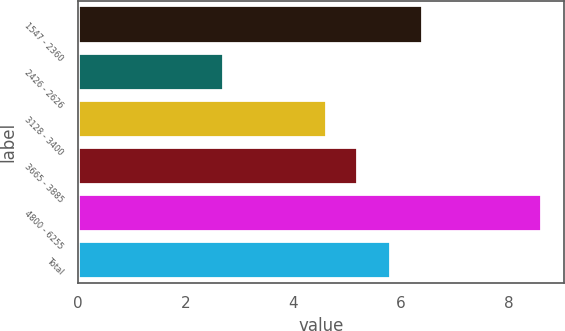Convert chart. <chart><loc_0><loc_0><loc_500><loc_500><bar_chart><fcel>1547 - 2360<fcel>2426 - 2626<fcel>3128 - 3400<fcel>3665 - 3885<fcel>4800 - 6255<fcel>Total<nl><fcel>6.39<fcel>2.7<fcel>4.6<fcel>5.19<fcel>8.6<fcel>5.8<nl></chart> 